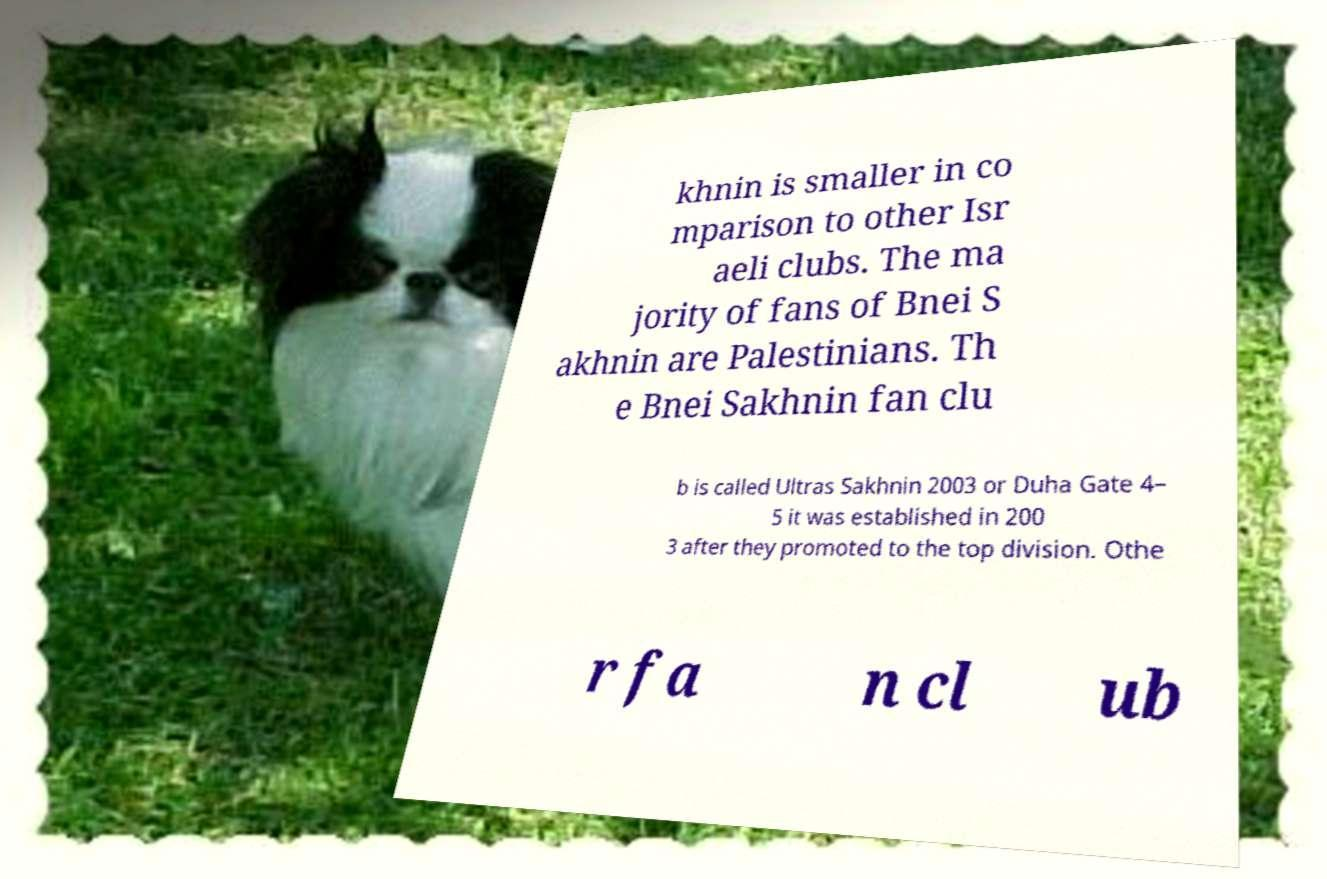Could you extract and type out the text from this image? khnin is smaller in co mparison to other Isr aeli clubs. The ma jority of fans of Bnei S akhnin are Palestinians. Th e Bnei Sakhnin fan clu b is called Ultras Sakhnin 2003 or Duha Gate 4– 5 it was established in 200 3 after they promoted to the top division. Othe r fa n cl ub 